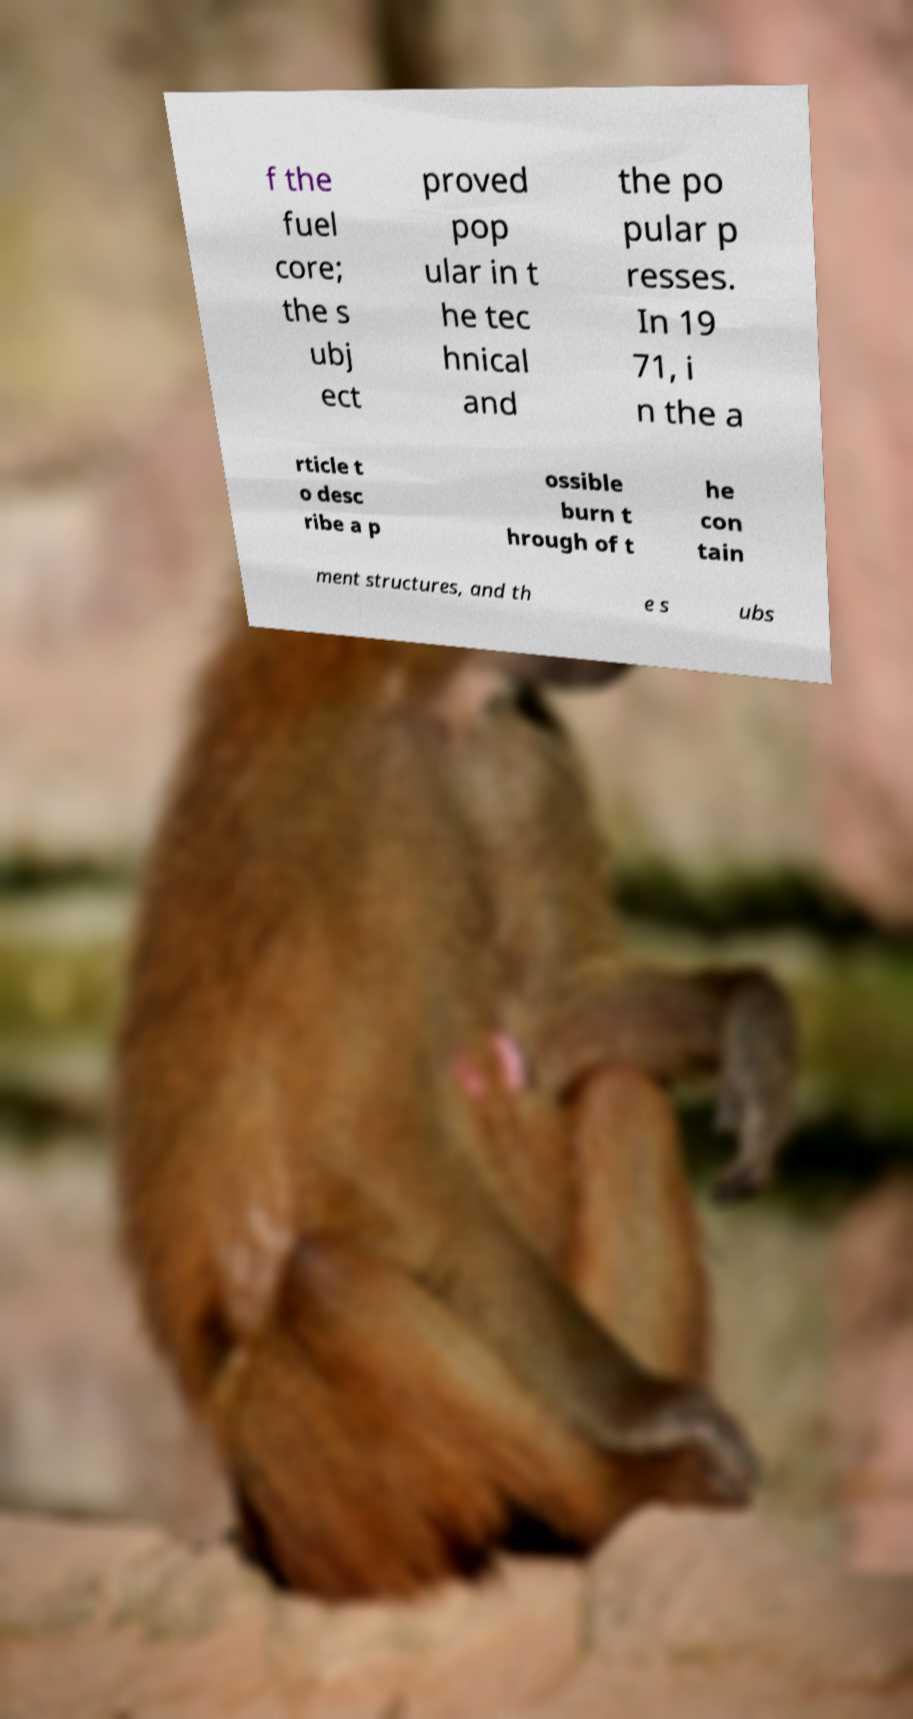There's text embedded in this image that I need extracted. Can you transcribe it verbatim? f the fuel core; the s ubj ect proved pop ular in t he tec hnical and the po pular p resses. In 19 71, i n the a rticle t o desc ribe a p ossible burn t hrough of t he con tain ment structures, and th e s ubs 